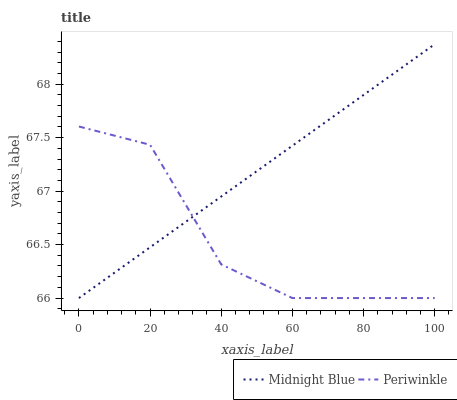Does Periwinkle have the minimum area under the curve?
Answer yes or no. Yes. Does Midnight Blue have the maximum area under the curve?
Answer yes or no. Yes. Does Midnight Blue have the minimum area under the curve?
Answer yes or no. No. Is Midnight Blue the smoothest?
Answer yes or no. Yes. Is Periwinkle the roughest?
Answer yes or no. Yes. Is Midnight Blue the roughest?
Answer yes or no. No. 